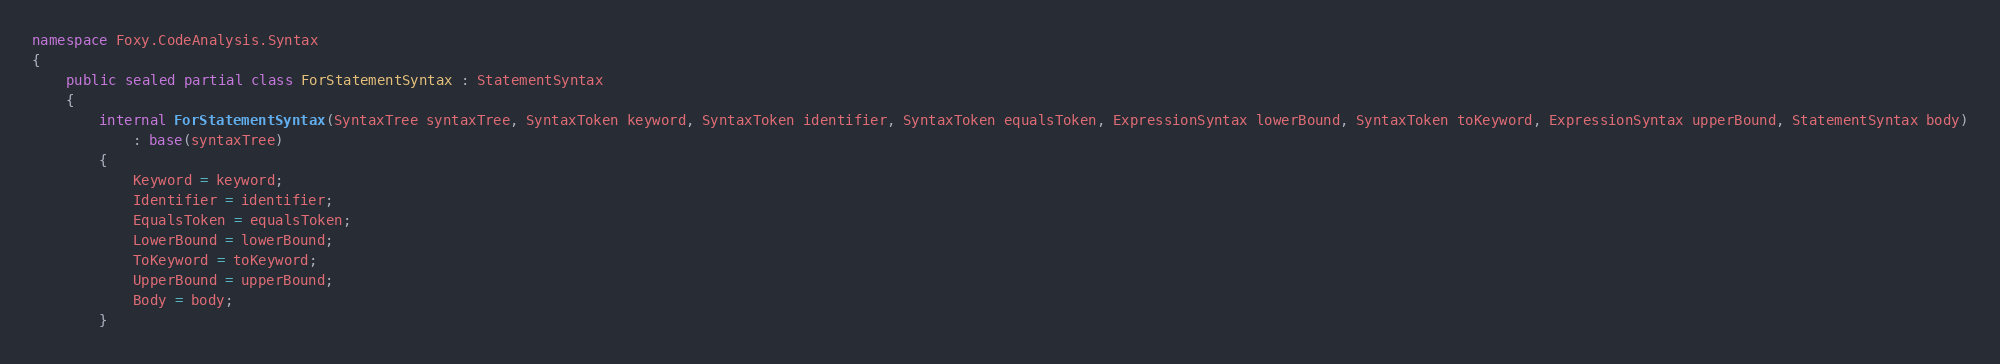Convert code to text. <code><loc_0><loc_0><loc_500><loc_500><_C#_>namespace Foxy.CodeAnalysis.Syntax
{
    public sealed partial class ForStatementSyntax : StatementSyntax
    {
        internal ForStatementSyntax(SyntaxTree syntaxTree, SyntaxToken keyword, SyntaxToken identifier, SyntaxToken equalsToken, ExpressionSyntax lowerBound, SyntaxToken toKeyword, ExpressionSyntax upperBound, StatementSyntax body)
            : base(syntaxTree)
        {
            Keyword = keyword;
            Identifier = identifier;
            EqualsToken = equalsToken;
            LowerBound = lowerBound;
            ToKeyword = toKeyword;
            UpperBound = upperBound;
            Body = body;
        }
</code> 